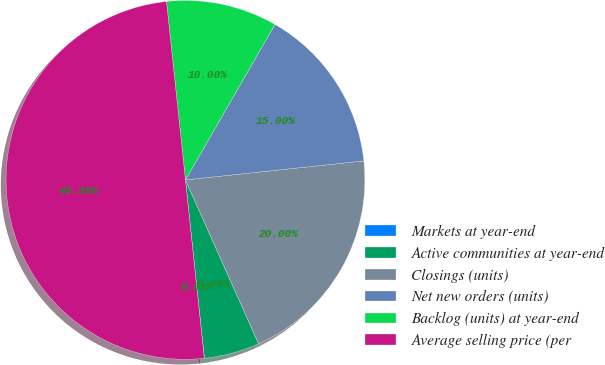Convert chart. <chart><loc_0><loc_0><loc_500><loc_500><pie_chart><fcel>Markets at year-end<fcel>Active communities at year-end<fcel>Closings (units)<fcel>Net new orders (units)<fcel>Backlog (units) at year-end<fcel>Average selling price (per<nl><fcel>0.01%<fcel>5.0%<fcel>20.0%<fcel>15.0%<fcel>10.0%<fcel>49.99%<nl></chart> 